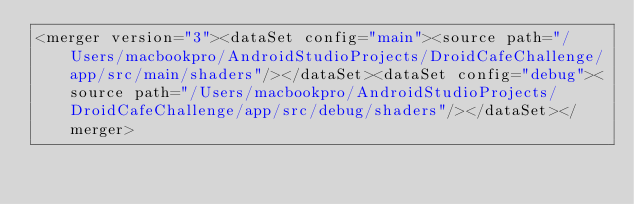<code> <loc_0><loc_0><loc_500><loc_500><_XML_><merger version="3"><dataSet config="main"><source path="/Users/macbookpro/AndroidStudioProjects/DroidCafeChallenge/app/src/main/shaders"/></dataSet><dataSet config="debug"><source path="/Users/macbookpro/AndroidStudioProjects/DroidCafeChallenge/app/src/debug/shaders"/></dataSet></merger></code> 